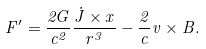<formula> <loc_0><loc_0><loc_500><loc_500>F ^ { \prime } = \frac { 2 G } { c ^ { 2 } } \frac { \dot { J } \times x } { r ^ { 3 } } - \frac { 2 } { c } v \times B .</formula> 